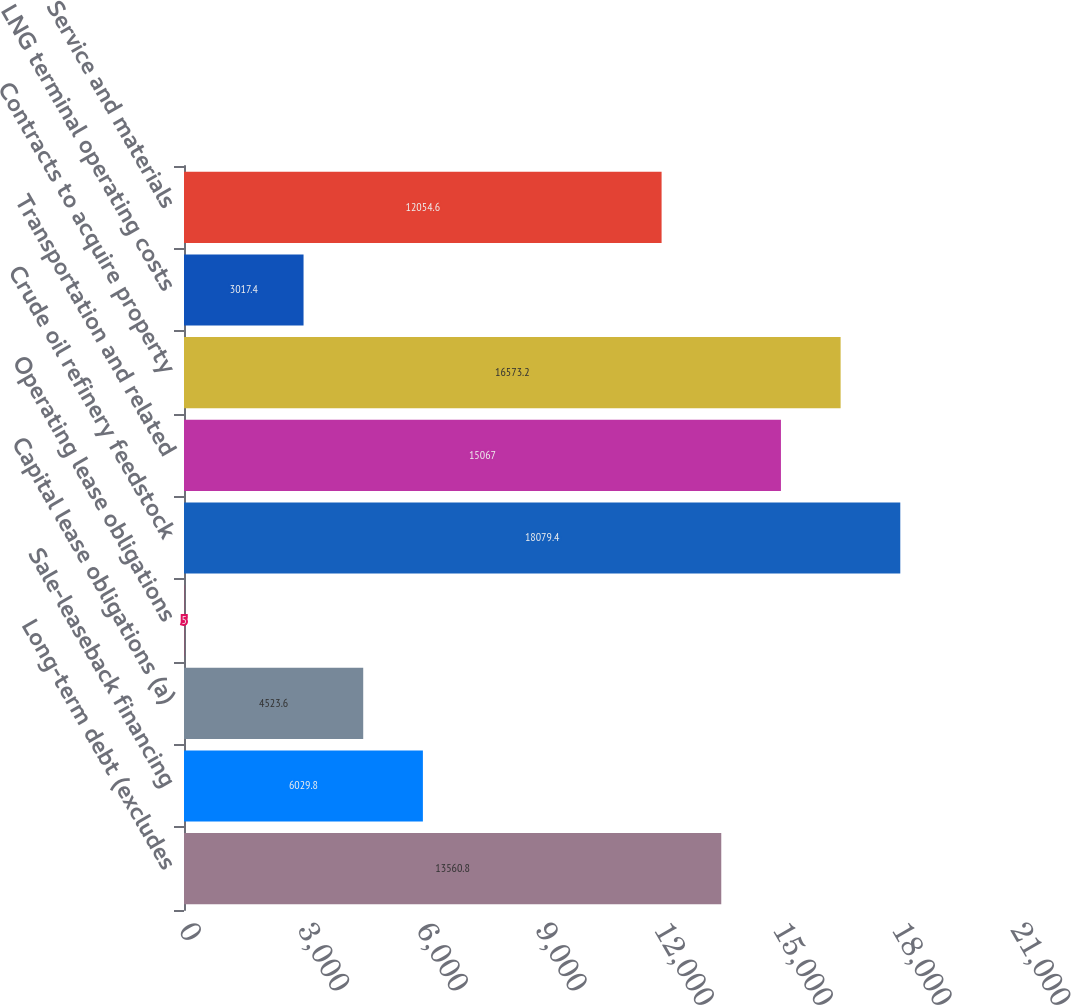<chart> <loc_0><loc_0><loc_500><loc_500><bar_chart><fcel>Long-term debt (excludes<fcel>Sale-leaseback financing<fcel>Capital lease obligations (a)<fcel>Operating lease obligations<fcel>Crude oil refinery feedstock<fcel>Transportation and related<fcel>Contracts to acquire property<fcel>LNG terminal operating costs<fcel>Service and materials<nl><fcel>13560.8<fcel>6029.8<fcel>4523.6<fcel>5<fcel>18079.4<fcel>15067<fcel>16573.2<fcel>3017.4<fcel>12054.6<nl></chart> 